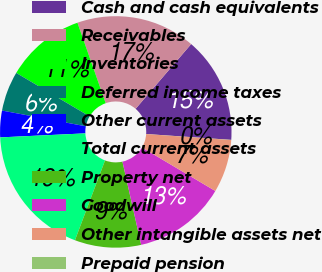<chart> <loc_0><loc_0><loc_500><loc_500><pie_chart><fcel>Cash and cash equivalents<fcel>Receivables<fcel>Inventories<fcel>Deferred income taxes<fcel>Other current assets<fcel>Total current assets<fcel>Property net<fcel>Goodwill<fcel>Other intangible assets net<fcel>Prepaid pension<nl><fcel>14.81%<fcel>16.66%<fcel>11.11%<fcel>5.56%<fcel>3.71%<fcel>18.51%<fcel>9.26%<fcel>12.96%<fcel>7.41%<fcel>0.02%<nl></chart> 